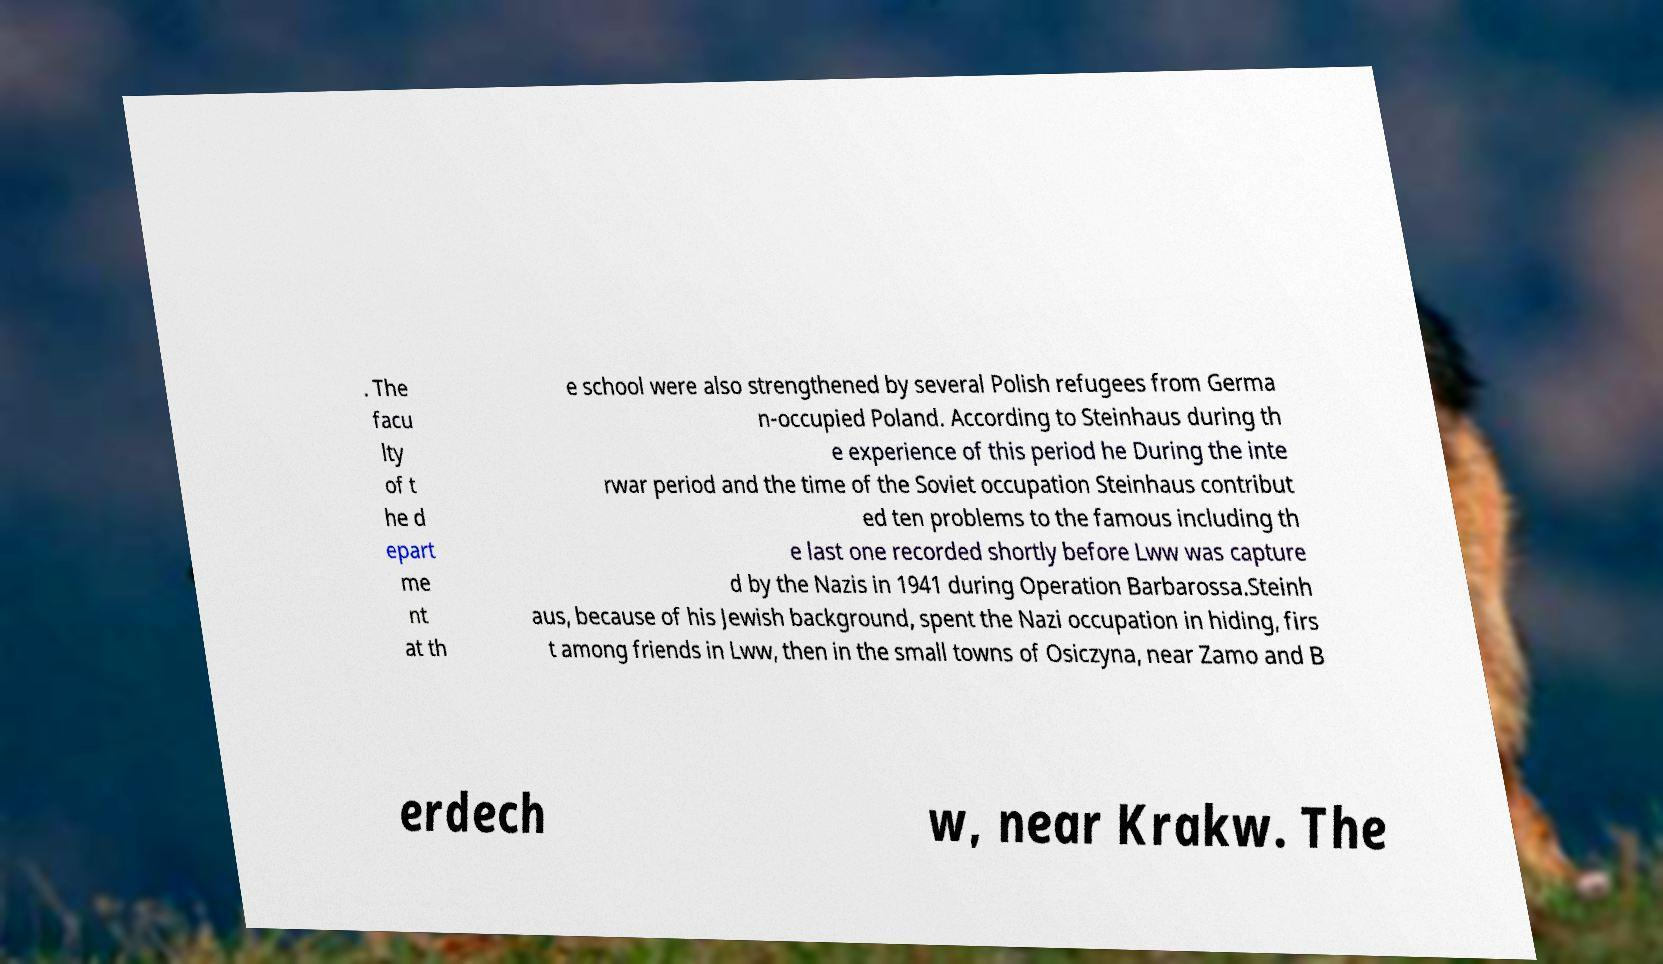Could you assist in decoding the text presented in this image and type it out clearly? . The facu lty of t he d epart me nt at th e school were also strengthened by several Polish refugees from Germa n-occupied Poland. According to Steinhaus during th e experience of this period he During the inte rwar period and the time of the Soviet occupation Steinhaus contribut ed ten problems to the famous including th e last one recorded shortly before Lww was capture d by the Nazis in 1941 during Operation Barbarossa.Steinh aus, because of his Jewish background, spent the Nazi occupation in hiding, firs t among friends in Lww, then in the small towns of Osiczyna, near Zamo and B erdech w, near Krakw. The 